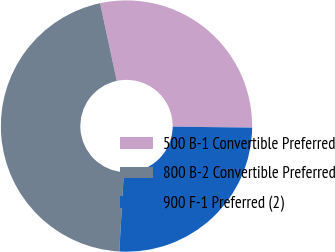<chart> <loc_0><loc_0><loc_500><loc_500><pie_chart><fcel>500 B-1 Convertible Preferred<fcel>800 B-2 Convertible Preferred<fcel>900 F-1 Preferred (2)<nl><fcel>28.57%<fcel>45.71%<fcel>25.71%<nl></chart> 